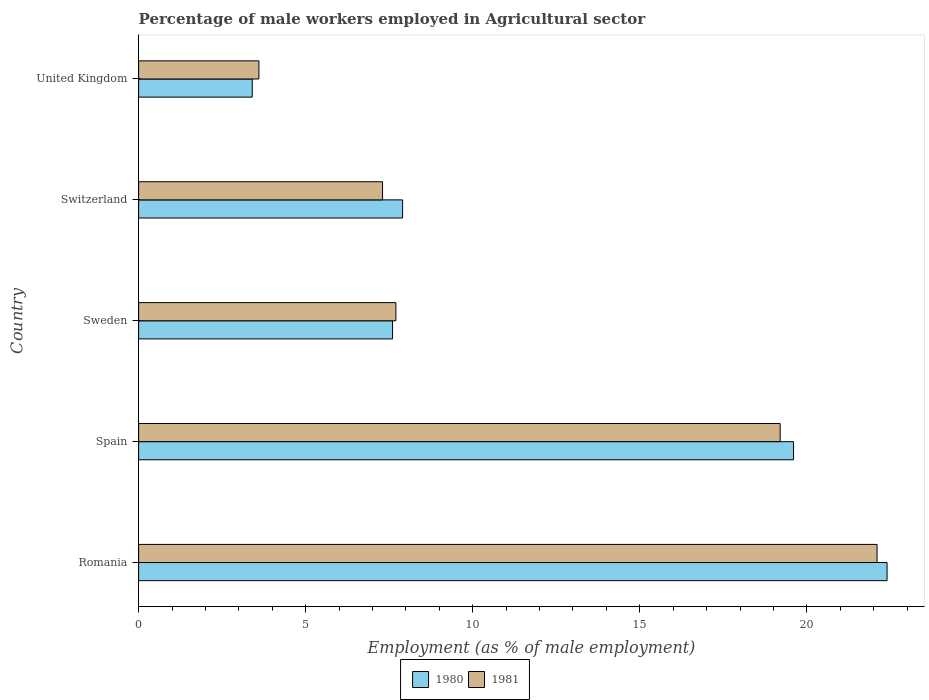How many groups of bars are there?
Ensure brevity in your answer.  5. Are the number of bars per tick equal to the number of legend labels?
Give a very brief answer. Yes. How many bars are there on the 5th tick from the top?
Offer a terse response. 2. What is the label of the 5th group of bars from the top?
Your answer should be compact. Romania. In how many cases, is the number of bars for a given country not equal to the number of legend labels?
Ensure brevity in your answer.  0. What is the percentage of male workers employed in Agricultural sector in 1981 in Spain?
Ensure brevity in your answer.  19.2. Across all countries, what is the maximum percentage of male workers employed in Agricultural sector in 1980?
Your answer should be compact. 22.4. Across all countries, what is the minimum percentage of male workers employed in Agricultural sector in 1980?
Make the answer very short. 3.4. In which country was the percentage of male workers employed in Agricultural sector in 1981 maximum?
Give a very brief answer. Romania. In which country was the percentage of male workers employed in Agricultural sector in 1981 minimum?
Make the answer very short. United Kingdom. What is the total percentage of male workers employed in Agricultural sector in 1980 in the graph?
Provide a succinct answer. 60.9. What is the difference between the percentage of male workers employed in Agricultural sector in 1980 in Romania and that in United Kingdom?
Your answer should be very brief. 19. What is the difference between the percentage of male workers employed in Agricultural sector in 1980 in Spain and the percentage of male workers employed in Agricultural sector in 1981 in Sweden?
Provide a short and direct response. 11.9. What is the average percentage of male workers employed in Agricultural sector in 1980 per country?
Keep it short and to the point. 12.18. What is the difference between the percentage of male workers employed in Agricultural sector in 1981 and percentage of male workers employed in Agricultural sector in 1980 in Spain?
Keep it short and to the point. -0.4. In how many countries, is the percentage of male workers employed in Agricultural sector in 1981 greater than 9 %?
Give a very brief answer. 2. What is the ratio of the percentage of male workers employed in Agricultural sector in 1980 in Spain to that in United Kingdom?
Your answer should be very brief. 5.76. What is the difference between the highest and the second highest percentage of male workers employed in Agricultural sector in 1981?
Ensure brevity in your answer.  2.9. What is the difference between the highest and the lowest percentage of male workers employed in Agricultural sector in 1980?
Provide a succinct answer. 19. In how many countries, is the percentage of male workers employed in Agricultural sector in 1981 greater than the average percentage of male workers employed in Agricultural sector in 1981 taken over all countries?
Provide a succinct answer. 2. Is the sum of the percentage of male workers employed in Agricultural sector in 1981 in Romania and United Kingdom greater than the maximum percentage of male workers employed in Agricultural sector in 1980 across all countries?
Provide a short and direct response. Yes. What does the 2nd bar from the bottom in United Kingdom represents?
Give a very brief answer. 1981. Are all the bars in the graph horizontal?
Provide a succinct answer. Yes. What is the difference between two consecutive major ticks on the X-axis?
Offer a very short reply. 5. Are the values on the major ticks of X-axis written in scientific E-notation?
Make the answer very short. No. How many legend labels are there?
Keep it short and to the point. 2. What is the title of the graph?
Provide a short and direct response. Percentage of male workers employed in Agricultural sector. Does "2012" appear as one of the legend labels in the graph?
Provide a succinct answer. No. What is the label or title of the X-axis?
Offer a very short reply. Employment (as % of male employment). What is the label or title of the Y-axis?
Ensure brevity in your answer.  Country. What is the Employment (as % of male employment) in 1980 in Romania?
Give a very brief answer. 22.4. What is the Employment (as % of male employment) in 1981 in Romania?
Give a very brief answer. 22.1. What is the Employment (as % of male employment) of 1980 in Spain?
Your answer should be compact. 19.6. What is the Employment (as % of male employment) of 1981 in Spain?
Your answer should be very brief. 19.2. What is the Employment (as % of male employment) of 1980 in Sweden?
Offer a very short reply. 7.6. What is the Employment (as % of male employment) of 1981 in Sweden?
Your answer should be very brief. 7.7. What is the Employment (as % of male employment) of 1980 in Switzerland?
Provide a short and direct response. 7.9. What is the Employment (as % of male employment) in 1981 in Switzerland?
Your answer should be compact. 7.3. What is the Employment (as % of male employment) in 1980 in United Kingdom?
Your response must be concise. 3.4. What is the Employment (as % of male employment) in 1981 in United Kingdom?
Your answer should be compact. 3.6. Across all countries, what is the maximum Employment (as % of male employment) of 1980?
Provide a short and direct response. 22.4. Across all countries, what is the maximum Employment (as % of male employment) of 1981?
Offer a very short reply. 22.1. Across all countries, what is the minimum Employment (as % of male employment) in 1980?
Your response must be concise. 3.4. Across all countries, what is the minimum Employment (as % of male employment) in 1981?
Provide a short and direct response. 3.6. What is the total Employment (as % of male employment) in 1980 in the graph?
Give a very brief answer. 60.9. What is the total Employment (as % of male employment) in 1981 in the graph?
Provide a succinct answer. 59.9. What is the difference between the Employment (as % of male employment) of 1980 in Romania and that in Spain?
Keep it short and to the point. 2.8. What is the difference between the Employment (as % of male employment) of 1981 in Romania and that in Spain?
Offer a very short reply. 2.9. What is the difference between the Employment (as % of male employment) of 1980 in Romania and that in Sweden?
Ensure brevity in your answer.  14.8. What is the difference between the Employment (as % of male employment) of 1980 in Romania and that in Switzerland?
Your response must be concise. 14.5. What is the difference between the Employment (as % of male employment) of 1981 in Romania and that in Switzerland?
Offer a terse response. 14.8. What is the difference between the Employment (as % of male employment) in 1980 in Romania and that in United Kingdom?
Ensure brevity in your answer.  19. What is the difference between the Employment (as % of male employment) of 1980 in Spain and that in Switzerland?
Provide a succinct answer. 11.7. What is the difference between the Employment (as % of male employment) of 1981 in Spain and that in Switzerland?
Provide a short and direct response. 11.9. What is the difference between the Employment (as % of male employment) of 1980 in Sweden and that in Switzerland?
Offer a terse response. -0.3. What is the difference between the Employment (as % of male employment) in 1981 in Switzerland and that in United Kingdom?
Keep it short and to the point. 3.7. What is the difference between the Employment (as % of male employment) of 1980 in Romania and the Employment (as % of male employment) of 1981 in Sweden?
Make the answer very short. 14.7. What is the difference between the Employment (as % of male employment) in 1980 in Romania and the Employment (as % of male employment) in 1981 in United Kingdom?
Your answer should be very brief. 18.8. What is the difference between the Employment (as % of male employment) of 1980 in Spain and the Employment (as % of male employment) of 1981 in Switzerland?
Ensure brevity in your answer.  12.3. What is the difference between the Employment (as % of male employment) in 1980 in Spain and the Employment (as % of male employment) in 1981 in United Kingdom?
Offer a terse response. 16. What is the difference between the Employment (as % of male employment) in 1980 in Switzerland and the Employment (as % of male employment) in 1981 in United Kingdom?
Give a very brief answer. 4.3. What is the average Employment (as % of male employment) in 1980 per country?
Make the answer very short. 12.18. What is the average Employment (as % of male employment) in 1981 per country?
Provide a succinct answer. 11.98. What is the difference between the Employment (as % of male employment) in 1980 and Employment (as % of male employment) in 1981 in Sweden?
Offer a terse response. -0.1. What is the difference between the Employment (as % of male employment) of 1980 and Employment (as % of male employment) of 1981 in Switzerland?
Ensure brevity in your answer.  0.6. What is the ratio of the Employment (as % of male employment) of 1981 in Romania to that in Spain?
Make the answer very short. 1.15. What is the ratio of the Employment (as % of male employment) of 1980 in Romania to that in Sweden?
Your answer should be very brief. 2.95. What is the ratio of the Employment (as % of male employment) in 1981 in Romania to that in Sweden?
Ensure brevity in your answer.  2.87. What is the ratio of the Employment (as % of male employment) in 1980 in Romania to that in Switzerland?
Provide a short and direct response. 2.84. What is the ratio of the Employment (as % of male employment) in 1981 in Romania to that in Switzerland?
Make the answer very short. 3.03. What is the ratio of the Employment (as % of male employment) of 1980 in Romania to that in United Kingdom?
Offer a terse response. 6.59. What is the ratio of the Employment (as % of male employment) in 1981 in Romania to that in United Kingdom?
Keep it short and to the point. 6.14. What is the ratio of the Employment (as % of male employment) of 1980 in Spain to that in Sweden?
Offer a terse response. 2.58. What is the ratio of the Employment (as % of male employment) of 1981 in Spain to that in Sweden?
Your answer should be very brief. 2.49. What is the ratio of the Employment (as % of male employment) in 1980 in Spain to that in Switzerland?
Your answer should be very brief. 2.48. What is the ratio of the Employment (as % of male employment) of 1981 in Spain to that in Switzerland?
Provide a short and direct response. 2.63. What is the ratio of the Employment (as % of male employment) of 1980 in Spain to that in United Kingdom?
Keep it short and to the point. 5.76. What is the ratio of the Employment (as % of male employment) in 1981 in Spain to that in United Kingdom?
Provide a succinct answer. 5.33. What is the ratio of the Employment (as % of male employment) of 1981 in Sweden to that in Switzerland?
Give a very brief answer. 1.05. What is the ratio of the Employment (as % of male employment) of 1980 in Sweden to that in United Kingdom?
Offer a terse response. 2.24. What is the ratio of the Employment (as % of male employment) in 1981 in Sweden to that in United Kingdom?
Ensure brevity in your answer.  2.14. What is the ratio of the Employment (as % of male employment) in 1980 in Switzerland to that in United Kingdom?
Your answer should be compact. 2.32. What is the ratio of the Employment (as % of male employment) of 1981 in Switzerland to that in United Kingdom?
Ensure brevity in your answer.  2.03. What is the difference between the highest and the second highest Employment (as % of male employment) of 1980?
Ensure brevity in your answer.  2.8. 